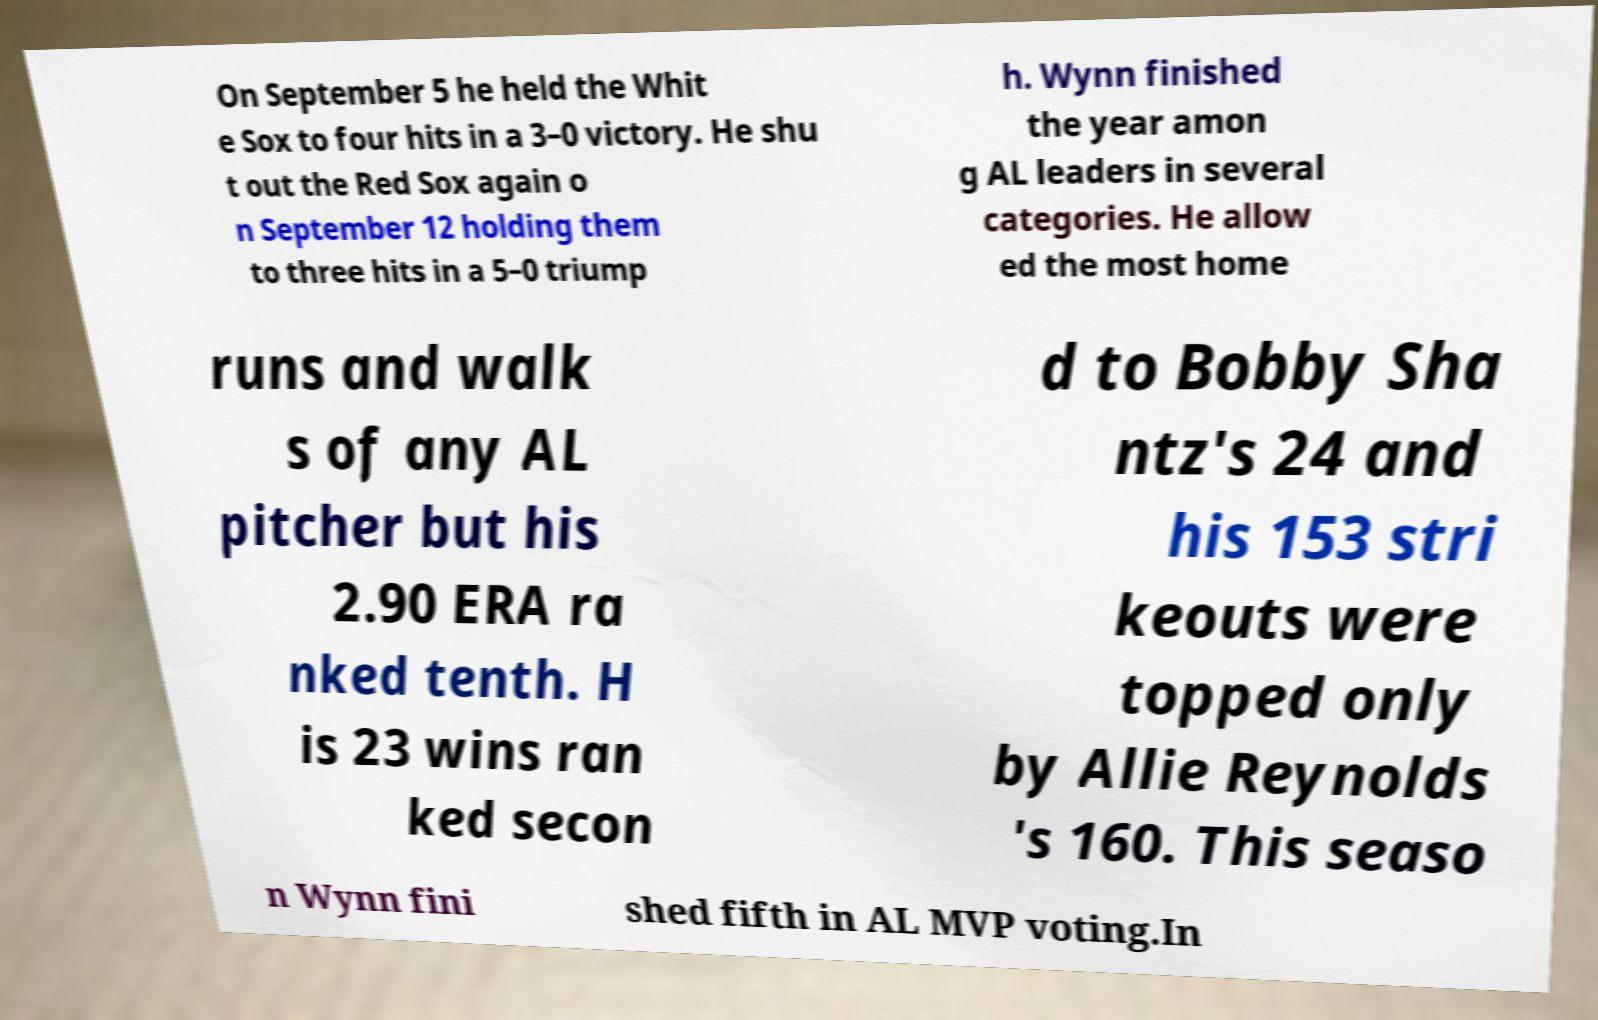Could you extract and type out the text from this image? On September 5 he held the Whit e Sox to four hits in a 3–0 victory. He shu t out the Red Sox again o n September 12 holding them to three hits in a 5–0 triump h. Wynn finished the year amon g AL leaders in several categories. He allow ed the most home runs and walk s of any AL pitcher but his 2.90 ERA ra nked tenth. H is 23 wins ran ked secon d to Bobby Sha ntz's 24 and his 153 stri keouts were topped only by Allie Reynolds 's 160. This seaso n Wynn fini shed fifth in AL MVP voting.In 